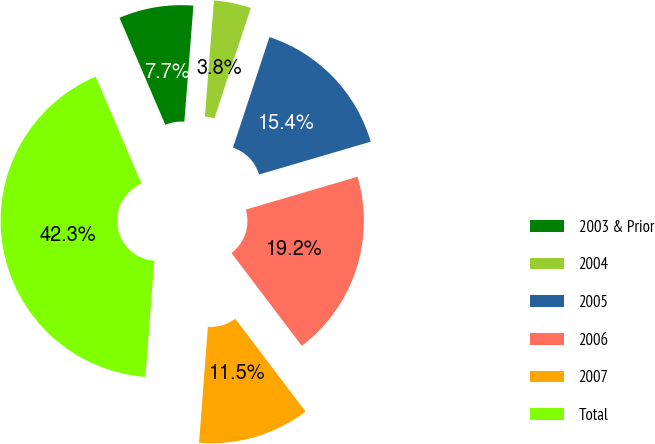Convert chart to OTSL. <chart><loc_0><loc_0><loc_500><loc_500><pie_chart><fcel>2003 & Prior<fcel>2004<fcel>2005<fcel>2006<fcel>2007<fcel>Total<nl><fcel>7.68%<fcel>3.83%<fcel>15.38%<fcel>19.23%<fcel>11.53%<fcel>42.35%<nl></chart> 